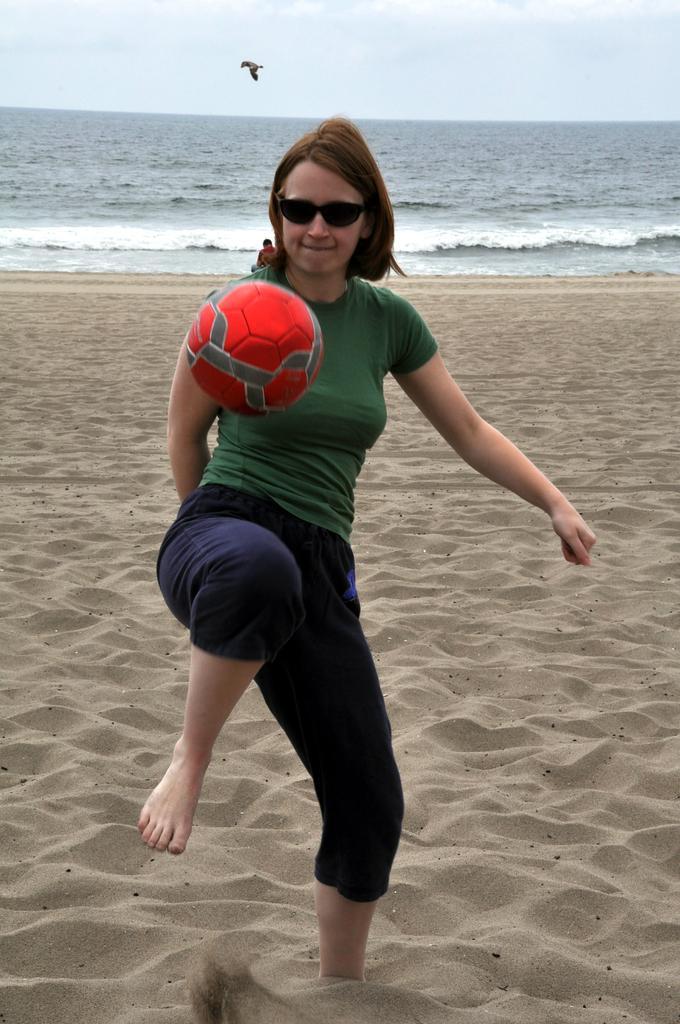Describe this image in one or two sentences. This is the picture of a sea. In the foreground there is a woman standing and there is a red color ball in the air. At the back there is a person and there is a water. At the top there is sky and there are clouds and there is a bird. At the bottom there is sand. 